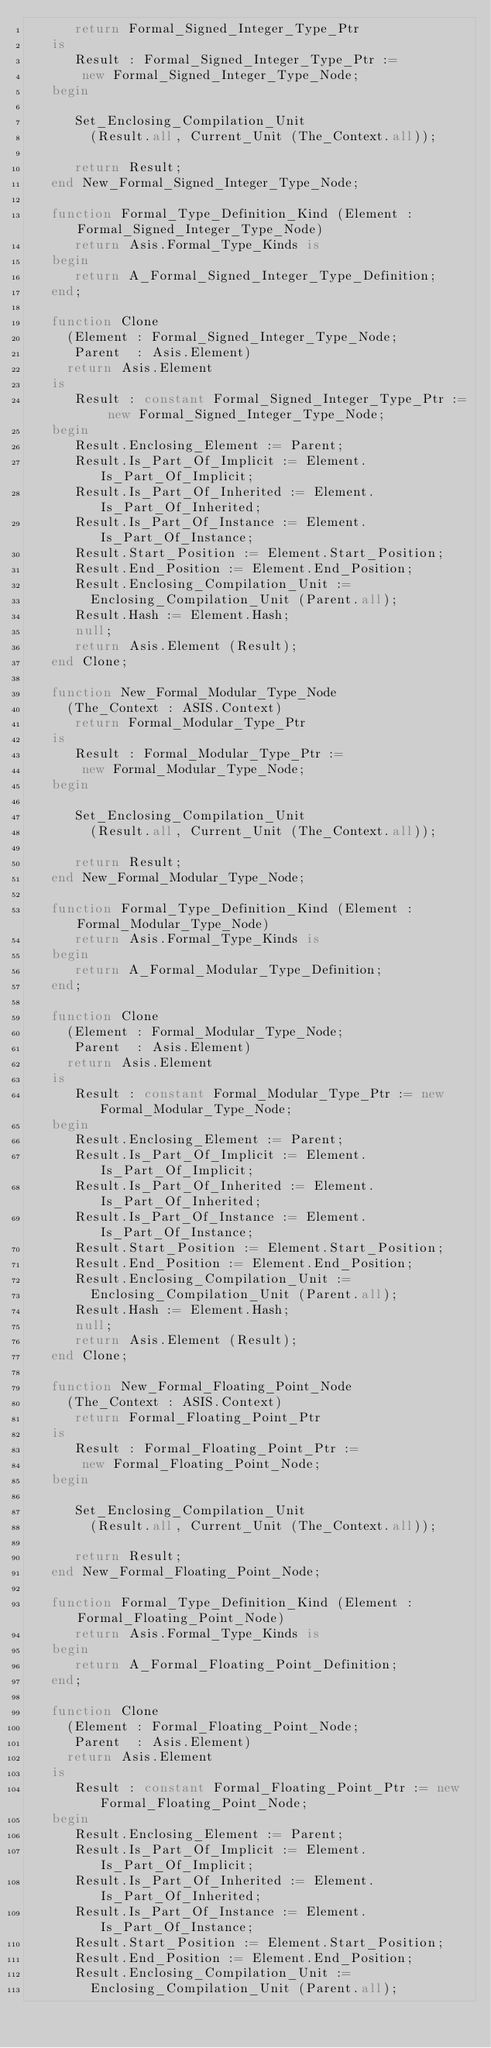<code> <loc_0><loc_0><loc_500><loc_500><_Ada_>      return Formal_Signed_Integer_Type_Ptr
   is
      Result : Formal_Signed_Integer_Type_Ptr :=
       new Formal_Signed_Integer_Type_Node;
   begin

      Set_Enclosing_Compilation_Unit
        (Result.all, Current_Unit (The_Context.all));

      return Result;
   end New_Formal_Signed_Integer_Type_Node;
  
   function Formal_Type_Definition_Kind (Element : Formal_Signed_Integer_Type_Node)
      return Asis.Formal_Type_Kinds is
   begin
      return A_Formal_Signed_Integer_Type_Definition;
   end;

   function Clone
     (Element : Formal_Signed_Integer_Type_Node;
      Parent  : Asis.Element)
     return Asis.Element
   is
      Result : constant Formal_Signed_Integer_Type_Ptr := new Formal_Signed_Integer_Type_Node;
   begin
      Result.Enclosing_Element := Parent;
      Result.Is_Part_Of_Implicit := Element.Is_Part_Of_Implicit;
      Result.Is_Part_Of_Inherited := Element.Is_Part_Of_Inherited;
      Result.Is_Part_Of_Instance := Element.Is_Part_Of_Instance;
      Result.Start_Position := Element.Start_Position;
      Result.End_Position := Element.End_Position;
      Result.Enclosing_Compilation_Unit :=
        Enclosing_Compilation_Unit (Parent.all);
      Result.Hash := Element.Hash;
      null;
      return Asis.Element (Result);
   end Clone;

   function New_Formal_Modular_Type_Node
     (The_Context : ASIS.Context)
      return Formal_Modular_Type_Ptr
   is
      Result : Formal_Modular_Type_Ptr :=
       new Formal_Modular_Type_Node;
   begin

      Set_Enclosing_Compilation_Unit
        (Result.all, Current_Unit (The_Context.all));

      return Result;
   end New_Formal_Modular_Type_Node;
  
   function Formal_Type_Definition_Kind (Element : Formal_Modular_Type_Node)
      return Asis.Formal_Type_Kinds is
   begin
      return A_Formal_Modular_Type_Definition;
   end;

   function Clone
     (Element : Formal_Modular_Type_Node;
      Parent  : Asis.Element)
     return Asis.Element
   is
      Result : constant Formal_Modular_Type_Ptr := new Formal_Modular_Type_Node;
   begin
      Result.Enclosing_Element := Parent;
      Result.Is_Part_Of_Implicit := Element.Is_Part_Of_Implicit;
      Result.Is_Part_Of_Inherited := Element.Is_Part_Of_Inherited;
      Result.Is_Part_Of_Instance := Element.Is_Part_Of_Instance;
      Result.Start_Position := Element.Start_Position;
      Result.End_Position := Element.End_Position;
      Result.Enclosing_Compilation_Unit :=
        Enclosing_Compilation_Unit (Parent.all);
      Result.Hash := Element.Hash;
      null;
      return Asis.Element (Result);
   end Clone;

   function New_Formal_Floating_Point_Node
     (The_Context : ASIS.Context)
      return Formal_Floating_Point_Ptr
   is
      Result : Formal_Floating_Point_Ptr :=
       new Formal_Floating_Point_Node;
   begin

      Set_Enclosing_Compilation_Unit
        (Result.all, Current_Unit (The_Context.all));

      return Result;
   end New_Formal_Floating_Point_Node;
  
   function Formal_Type_Definition_Kind (Element : Formal_Floating_Point_Node)
      return Asis.Formal_Type_Kinds is
   begin
      return A_Formal_Floating_Point_Definition;
   end;

   function Clone
     (Element : Formal_Floating_Point_Node;
      Parent  : Asis.Element)
     return Asis.Element
   is
      Result : constant Formal_Floating_Point_Ptr := new Formal_Floating_Point_Node;
   begin
      Result.Enclosing_Element := Parent;
      Result.Is_Part_Of_Implicit := Element.Is_Part_Of_Implicit;
      Result.Is_Part_Of_Inherited := Element.Is_Part_Of_Inherited;
      Result.Is_Part_Of_Instance := Element.Is_Part_Of_Instance;
      Result.Start_Position := Element.Start_Position;
      Result.End_Position := Element.End_Position;
      Result.Enclosing_Compilation_Unit :=
        Enclosing_Compilation_Unit (Parent.all);</code> 